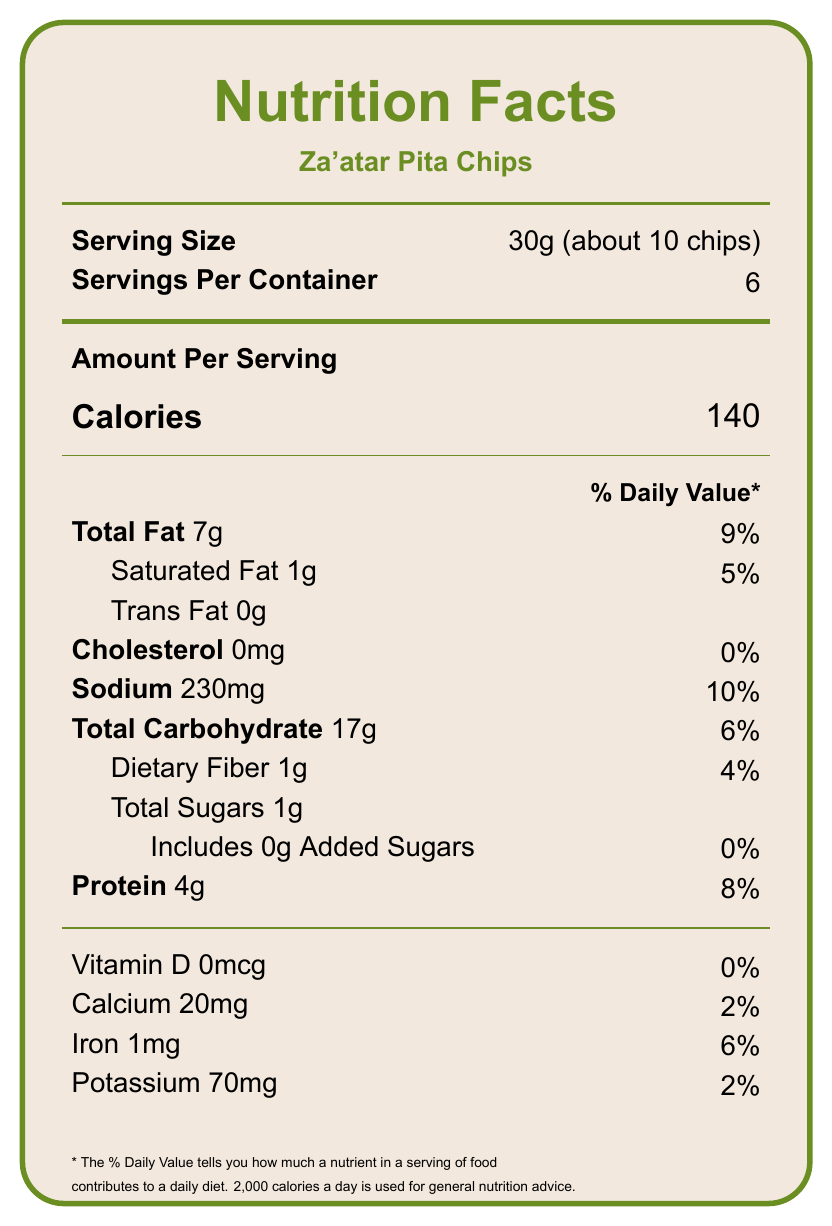what is the serving size? The serving size is listed in the document under the "Serving Size" label, which is "30g (about 10 chips)".
Answer: 30g (about 10 chips) how much protein is in each serving? The protein content per serving is directly listed in the document as "Protein 4g".
Answer: 4g how many calories are in one serving of Za'atar Pita Chips? The calorie content is provided in large font in the document and states "Calories 140".
Answer: 140 how much sodium is present per serving? The sodium content per serving is explicitly noted under the "Sodium" section, which states "230mg".
Answer: 230mg what percentage of the daily value for protein does one serving of Za'atar Pita Chips provide? The percentage of the daily value for protein is provided next to the protein content and states "8%".
Answer: 8% what is the total fat content per serving? The total fat content per serving is indicated as "Total Fat 7g".
Answer: 7g how much dietary fiber is in each serving? Under the carbohydrate section, dietary fiber is listed as "Dietary Fiber 1g".
Answer: 1g are there any added sugars in these chips? The document specifies "Includes 0g Added Sugars", indicating that there are no added sugars in the chips.
Answer: No how many servings are in one container? A. 4 B. 6 C. 8 The number of servings per container is provided as "Servings Per Container: 6".
Answer: B which of the following vitamins and minerals are present in significant amounts in Za'atar Pita Chips? A. Vitamin D B. Calcium C. Potassium D. Iron While Vitamin D and Calcium have very low daily values, Iron is listed with a 6% daily value, which is higher than the others listed.
Answer: D are the Za'atar Pita Chips kosher certified? The document mentions that the product is "kosher certified".
Answer: Yes is trans fat present in these chips? Yes/No The trans fat content is explicitly listed as "Trans Fat 0g".
Answer: No summarize the main nutrients present in Za'atar Pita Chips. The document provides a detailed breakdown of the nutrient content per serving, highlighting key nutrients such as calories, fat, protein, sodium, carbohydrates, fiber, and sugars.
Answer: Za'atar Pita Chips provide 140 calories, 7g of total fat, 4g of protein, 230mg of sodium, 17g of carbohydrates, 1g of fiber, and 1g of total sugars per 30g serving. They do not contain trans fat, cholesterol, or added sugars. what health claims does this product make? Information about specific health claims made by the product is not detailed in the visual document. While the health-related nutrients are mentioned, specific health claims are not included in the visual information.
Answer: Cannot be determined what is the percentage of daily value for saturated fat? The daily value percentage for saturated fat is visible next to its amount, stating "5%".
Answer: 5% 